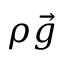Convert formula to latex. <formula><loc_0><loc_0><loc_500><loc_500>\rho \vec { g }</formula> 